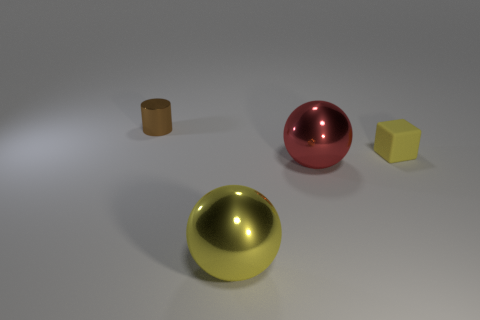Add 2 small brown objects. How many objects exist? 6 Subtract all cylinders. How many objects are left? 3 Subtract all brown matte balls. Subtract all tiny cubes. How many objects are left? 3 Add 3 large yellow metal objects. How many large yellow metal objects are left? 4 Add 1 cyan matte cylinders. How many cyan matte cylinders exist? 1 Subtract 1 yellow cubes. How many objects are left? 3 